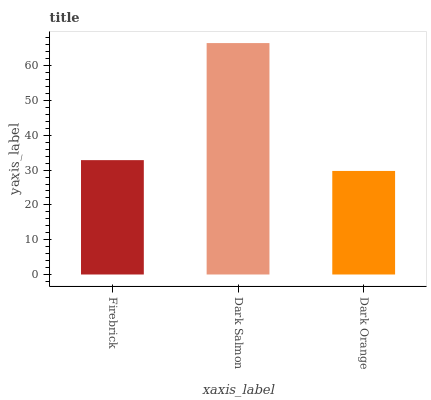Is Dark Orange the minimum?
Answer yes or no. Yes. Is Dark Salmon the maximum?
Answer yes or no. Yes. Is Dark Salmon the minimum?
Answer yes or no. No. Is Dark Orange the maximum?
Answer yes or no. No. Is Dark Salmon greater than Dark Orange?
Answer yes or no. Yes. Is Dark Orange less than Dark Salmon?
Answer yes or no. Yes. Is Dark Orange greater than Dark Salmon?
Answer yes or no. No. Is Dark Salmon less than Dark Orange?
Answer yes or no. No. Is Firebrick the high median?
Answer yes or no. Yes. Is Firebrick the low median?
Answer yes or no. Yes. Is Dark Orange the high median?
Answer yes or no. No. Is Dark Salmon the low median?
Answer yes or no. No. 